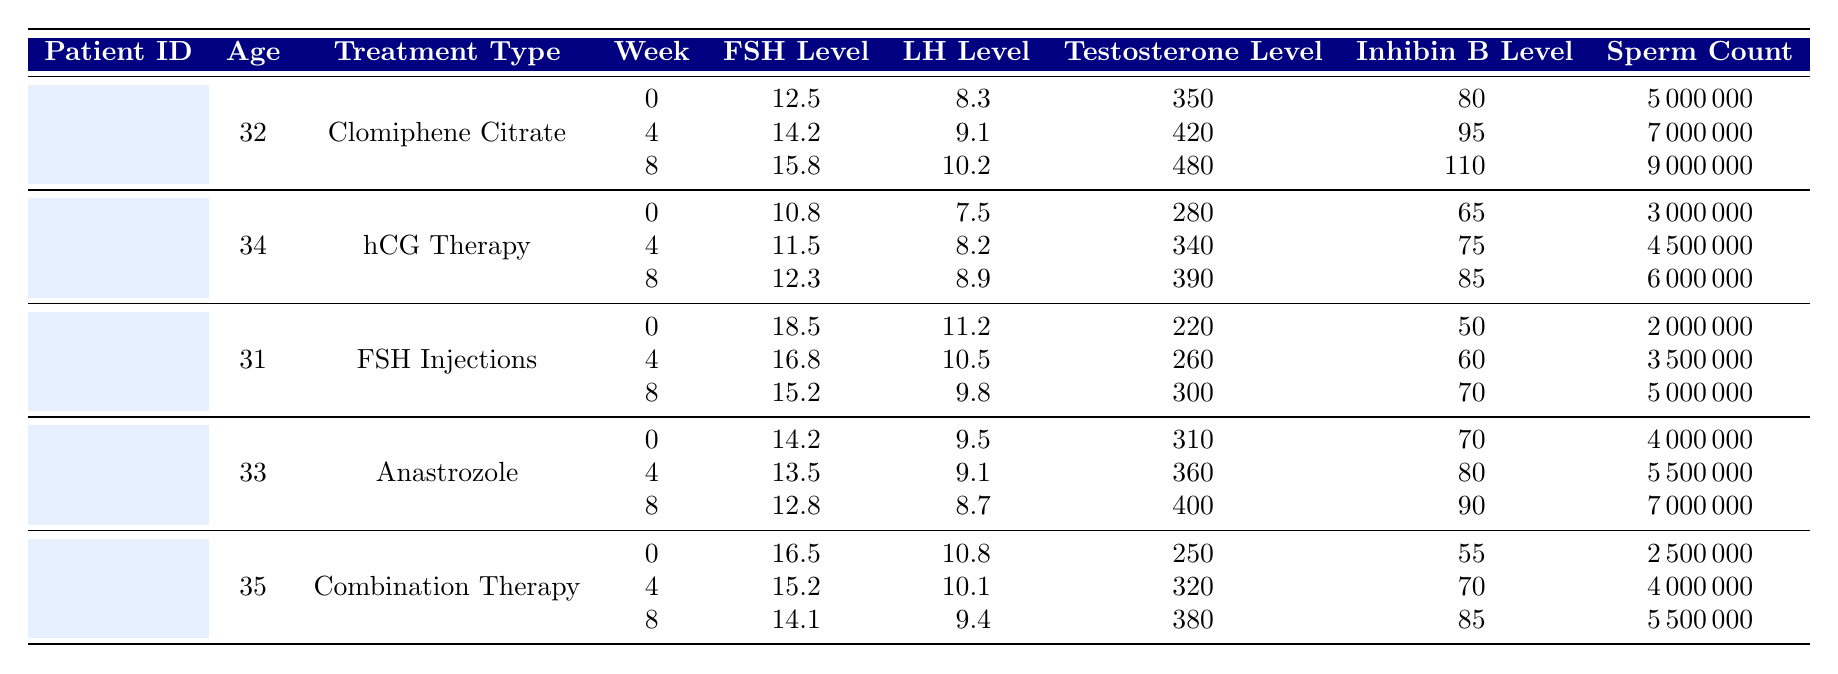What is the FSH level for patient P001 at week 4? According to the table, patient P001's FSH level at week 4 is specified in the corresponding row, which shows that it is 14.2.
Answer: 14.2 What treatment did patient P003 undergo? By looking at the table, patient P003 is listed under the treatment type "FSH Injections."
Answer: FSH Injections Which patient had the highest testosterone level at week 0? To find the highest testosterone level at week 0, we compare the testosterone levels of all patients at week 0: P001 has 350, P002 has 280, P003 has 220, P004 has 310, and P005 has 250. The highest value is 350 from patient P001.
Answer: P001 What was the change in sperm count for patient P002 from week 0 to week 8? Patient P002's sperm count at week 0 is 3,000,000, and at week 8 it is 6,000,000. The change can be calculated as 6,000,000 - 3,000,000 = 3,000,000.
Answer: 3,000,000 At which week did patient P004 have the lowest FSH level? By examining the FSH levels for patient P004 across all weeks: week 0 is 14.2, week 4 is 13.5, and week 8 is 12.8. The lowest level appears at week 8, which is 12.8.
Answer: Week 8 What is the average LH level for patient P005 over all weeks? The LH levels for patient P005 are: week 0 is 10.8, week 4 is 10.1, and week 8 is 9.4. To find the average, we calculate (10.8 + 10.1 + 9.4) / 3 = 10.1.
Answer: 10.1 Is the testosterone level for patient P003 always below 300 across all weeks? Checking the testosterone levels for patient P003: week 0 is 220, week 4 is 260, and week 8 is 300. The testosterone level at week 8 is exactly 300, so it is not always below that value.
Answer: No What was the highest sperm count recorded among all patients at any week? By reviewing the sperm counts for all patients at all weeks, we see P001 has a maximum of 9,000,000 at week 8, while other patients like P002, P003, P004, and P005 have lower counts. Therefore, the highest is 9,000,000 from patient P001.
Answer: 9,000,000 Which treatment type had the least increase in FSH levels from week 0 to week 8? We need to observe the FSH levels for each treatment type from week 0 to 8. For Clomiphene Citrate (P001), the increase is 3.3 (15.8 - 12.5), for hCG Therapy (P002) it is 1.5 (12.3 - 10.8), for FSH Injections (P003) it is -3.3 (15.2 - 18.5), for Anastrozole (P004) it is -1.4 (12.8 - 14.2), and for Combination Therapy (P005) it is -2.4 (14.1 - 16.5). The least increase (note that decreases can be considered) occurs with FSH Injections at -3.3.
Answer: FSH Injections What is the trend in Inhibin B levels for patient P004 over the weeks? Looking at patient P004, the Inhibin B levels are 70 (week 0), 80 (week 4), and 90 (week 8). These levels are increasing over time: 70 < 80 < 90.
Answer: Increasing 